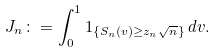Convert formula to latex. <formula><loc_0><loc_0><loc_500><loc_500>J _ { n } \colon = \int _ { 0 } ^ { 1 } 1 _ { \{ S _ { n } ( v ) \geq z _ { n } \sqrt { n } \} } \, d v .</formula> 